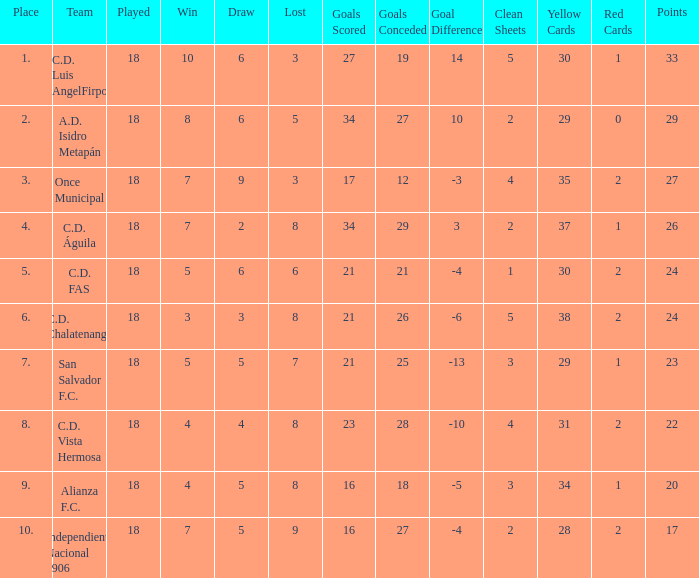What are the number of goals conceded that has a played greater than 18? 0.0. 